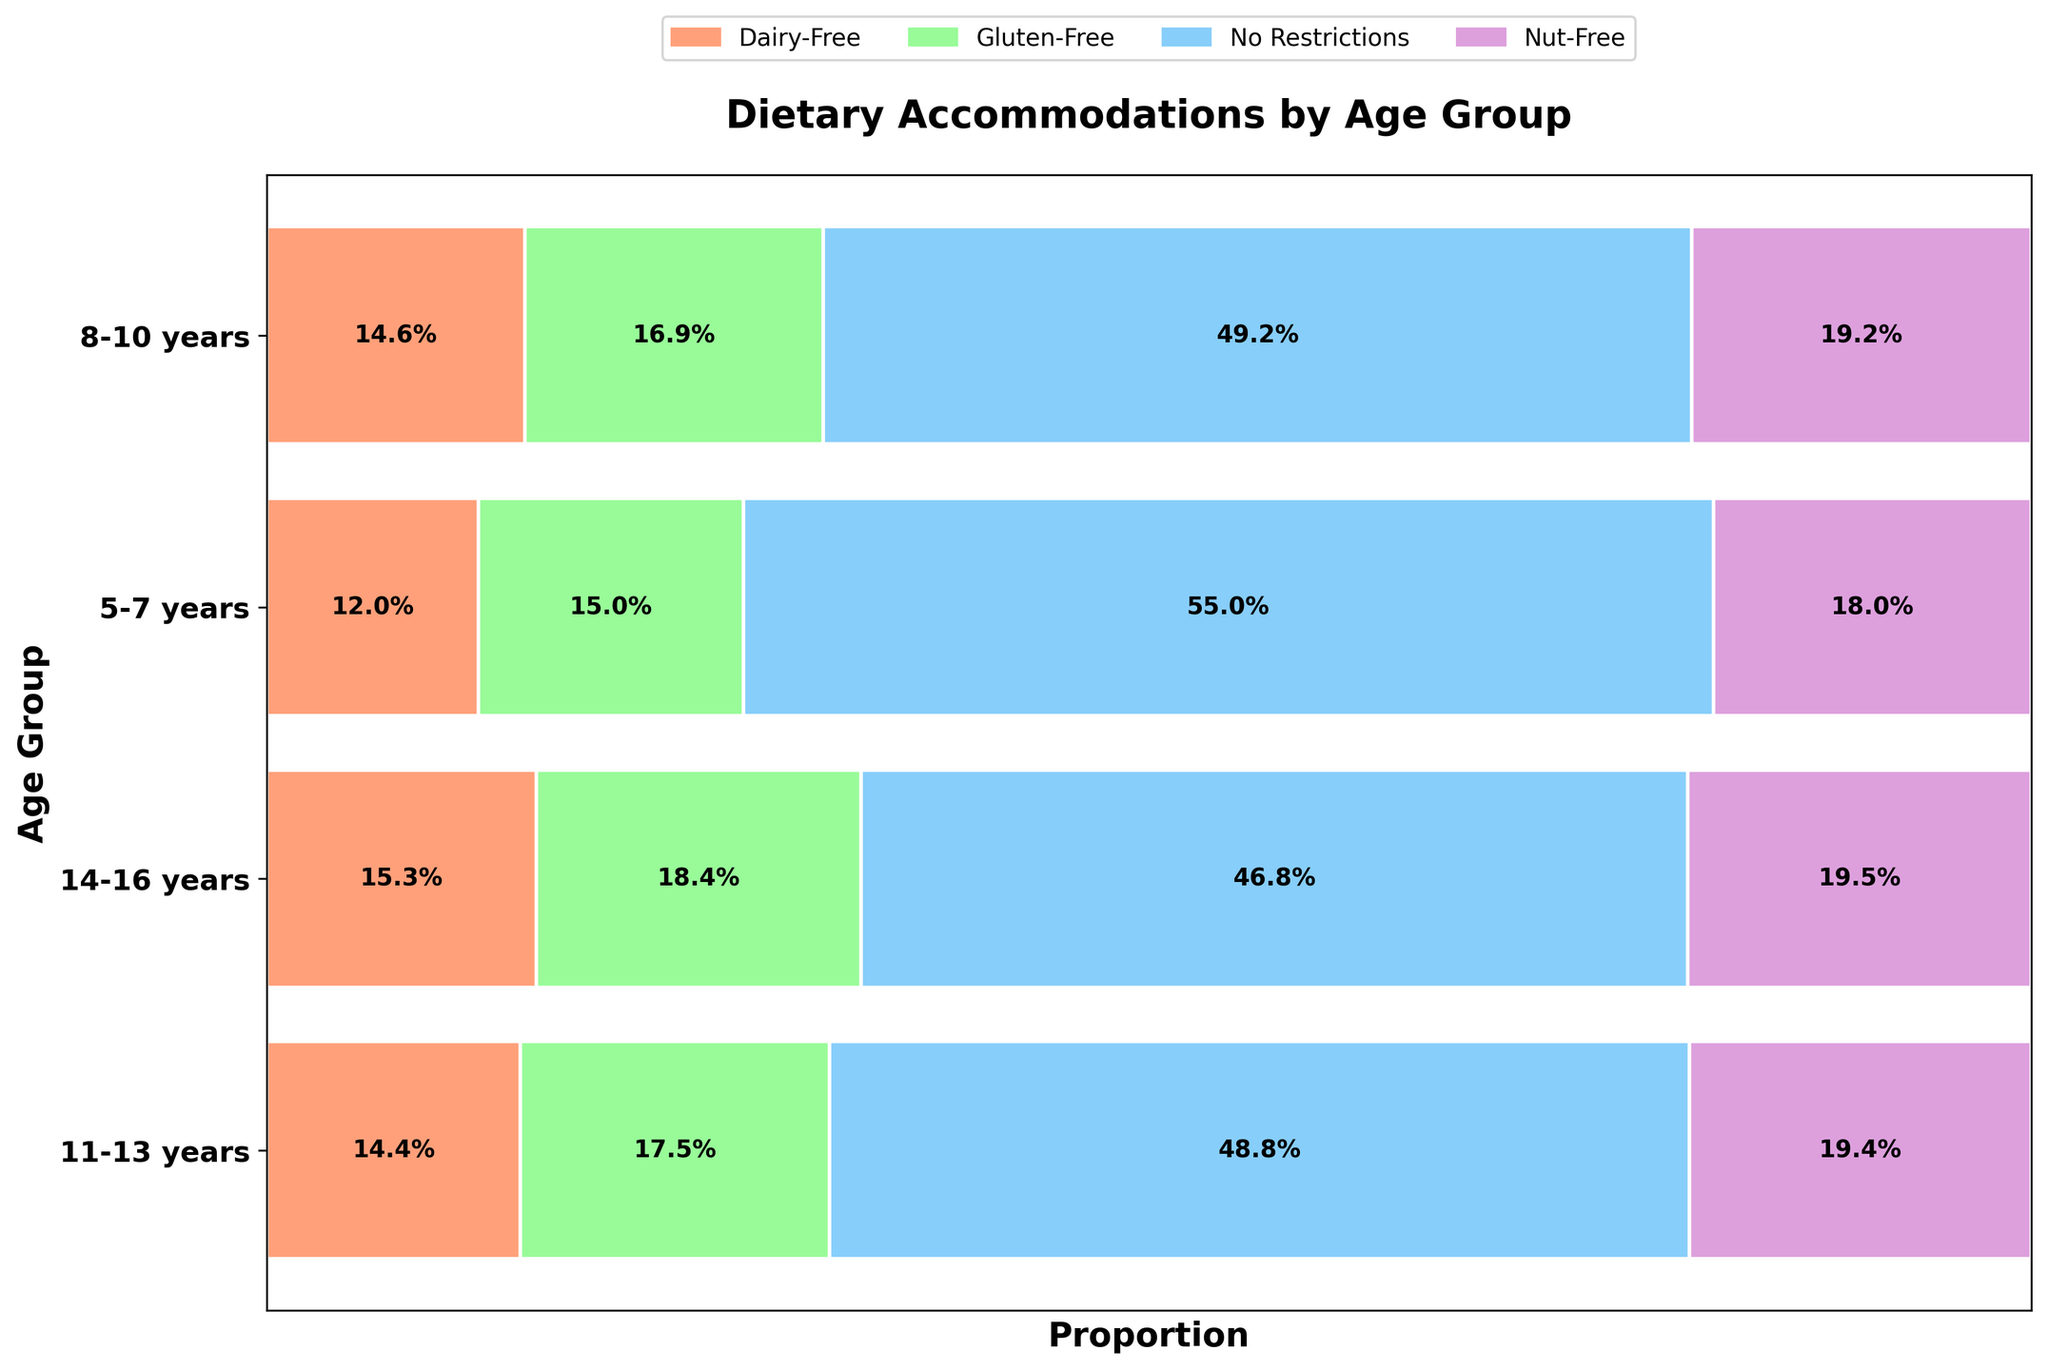What is the highest dietary accommodation requirement for the 5-7 years age group? The dietary accommodation with the highest requirement can be identified by finding the longest horizontal bar for the 5-7 years age group. The "No Restrictions" category has the longest bar.
Answer: No Restrictions What percentage of 14-16 years age group have Nut-Free accommodation? First, locate the bar representing the 14-16 years age group. Within this group, identify the segment for "Nut-Free" (usually highlighted in one color). The percentage is annotated on the bar.
Answer: 18.5% In which age group is the proportion of Dairy-Free accommodation the smallest? Compare the lengths of the Dairy-Free bars across all age groups. The smallest segment appears in the 5-7 years age group.
Answer: 5-7 years Which dietary accommodation is more prevalent in the 11-13 years age group compared to 8-10 years? For each dietary category within the 11-13 years and 8-10 years groups, compare the segment lengths. The Gluten-Free bar is longer in the 11-13 years group than in the 8-10 years group.
Answer: Gluten-Free What is the combined percentage of students requiring any dietary accommodation in the 8-10 years age group? First, sum the percentages of Gluten-Free, Dairy-Free, and Nut-Free accommodations for the 8-10 years group. The bar segments are annotated with their respective percentages: 16.6% + 14.3% + 18.9%.
Answer: 49.8% How many different types of dietary accommodations are displayed in the plot? Count the number of unique categories represented in the legend and within the bars across all age groups.
Answer: 4 Does the proportion of students with no dietary restrictions increase or decrease with age? Examine the "No Restrictions" category across all age groups from 5-7 years to 14-16 years. Observe if the bar segments increase or decrease in length. They generally widen, indicating an increase.
Answer: Increase Which age group has the closest percentage between Nut-Free and Dairy-Free accommodations? Compare the percentages of Nut-Free and Dairy-Free accommodations for each age group. For the 11-13 years group, the percentages are closest (20% for Nut-Free and 14.7% for Dairy-Free).
Answer: 11-13 years What is the difference in the proportion of Gluten-Free accommodations between the oldest and youngest age groups? Subtract the Gluten-Free proportion for the 5-7 years group from the 14-16 years group. The values are 19.5% (14-16 years) and 12.6% (5-7 years).
Answer: 6.9% 